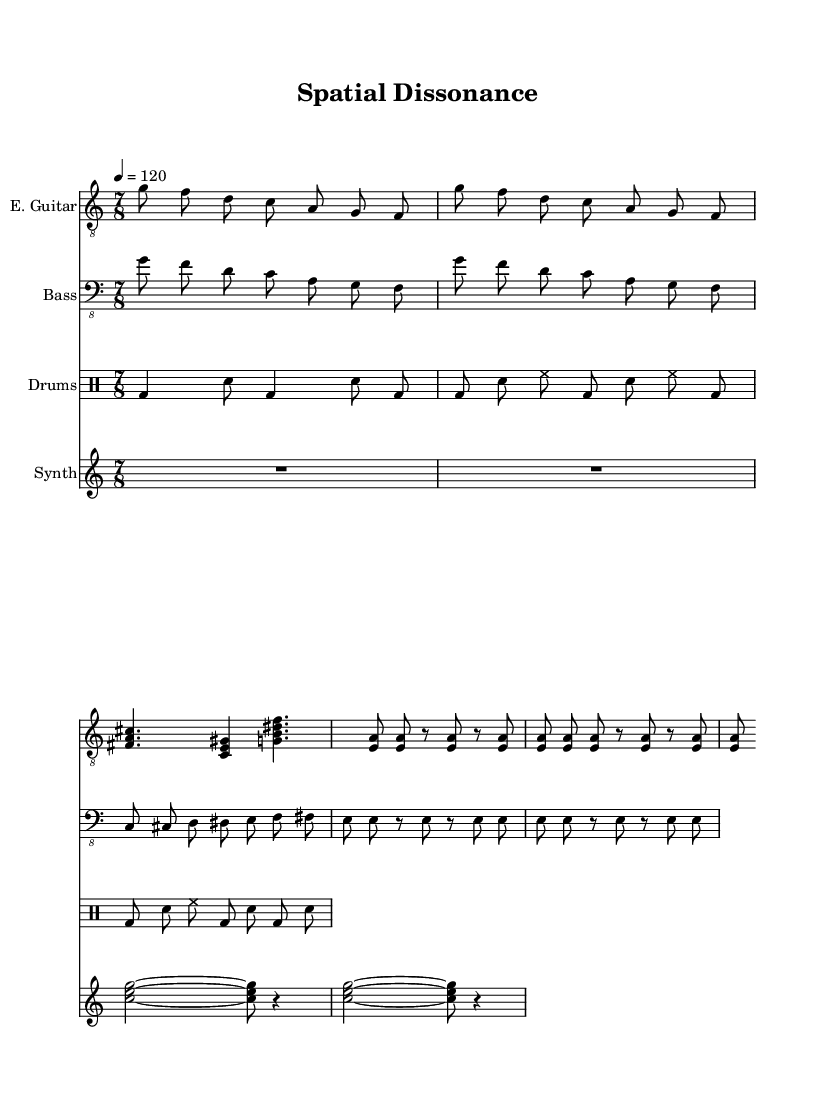What is the time signature of this music? The time signature is indicated at the beginning of the score as 7/8, which means there are seven beats in each measure and an eighth note receives one beat.
Answer: 7/8 What is the tempo marking for this piece? The tempo marking is 4 = 120, which indicates that the piece should be played at 120 beats per minute, with the quarter note receiving one beat.
Answer: 120 How many times is the intro/main riff repeated? The score shows a repeat mark for the intro/main riff, indicating that it is played two times before moving on to the next section.
Answer: 2 What instruments are featured in this score? The score explicitly lists E. Guitar, Bass, Drums, and Synth as the assigned instruments in the respective staves, indicating their presence in the composition.
Answer: E. Guitar, Bass, Drums, Synth Describe the rhythm pattern used in the verse for the bass guitar. The bass guitar part in the verse consists of a chromatic walk-up starting from C, progressing up through each consecutive note (C, C#, D, D#, E, F, F#) with eighth note values, creating a rising pattern that complements the dissonance of the verse chords.
Answer: Chromatic walk-up What is the general characteristic of the chorus section in terms of guitar technique? The chorus section uses palm-muted power chords, which are indicated by the notation showing dashes (indicating palm muting) after the chord names, creating a heavier and more aggressive sound typical of metal music.
Answer: Palm-muted power chords How does the synthesizer part contribute to the overall atmosphere of the composition? The synthesizer part primarily consists of sustained chords and rests, allowing for ambient soundscapes between the sections. This ambient quality helps create a spacious and atmospheric feel that complements the avant-garde elements of the metal genre.
Answer: Ambient soundscapes 